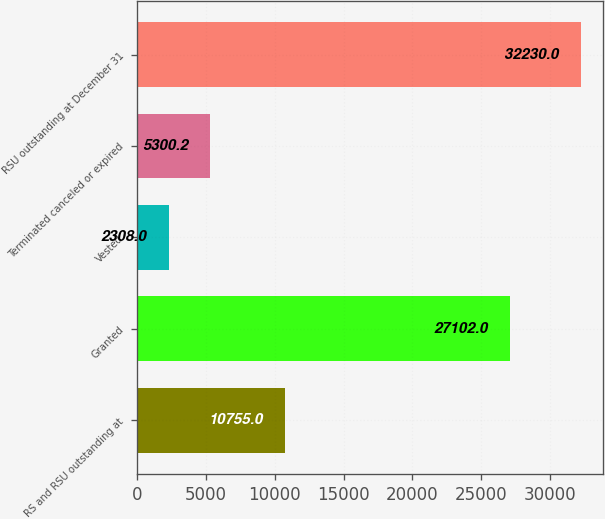Convert chart. <chart><loc_0><loc_0><loc_500><loc_500><bar_chart><fcel>RS and RSU outstanding at<fcel>Granted<fcel>Vested<fcel>Terminated canceled or expired<fcel>RSU outstanding at December 31<nl><fcel>10755<fcel>27102<fcel>2308<fcel>5300.2<fcel>32230<nl></chart> 